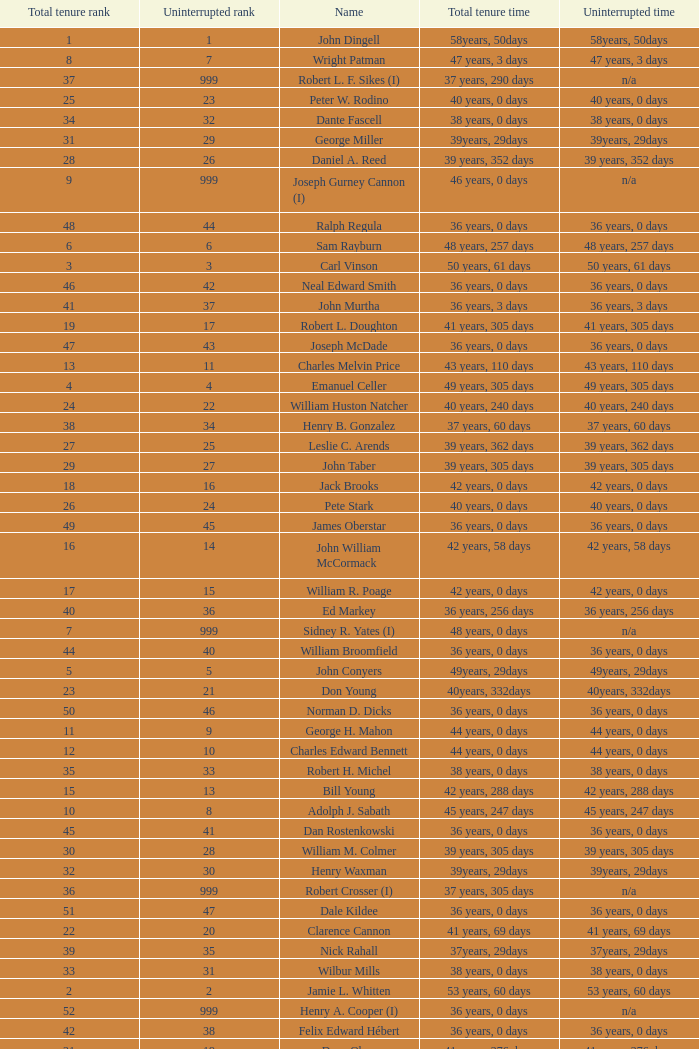Who has a total tenure time and uninterrupted time of 36 years, 0 days, as well as a total tenure rank of 49? James Oberstar. 